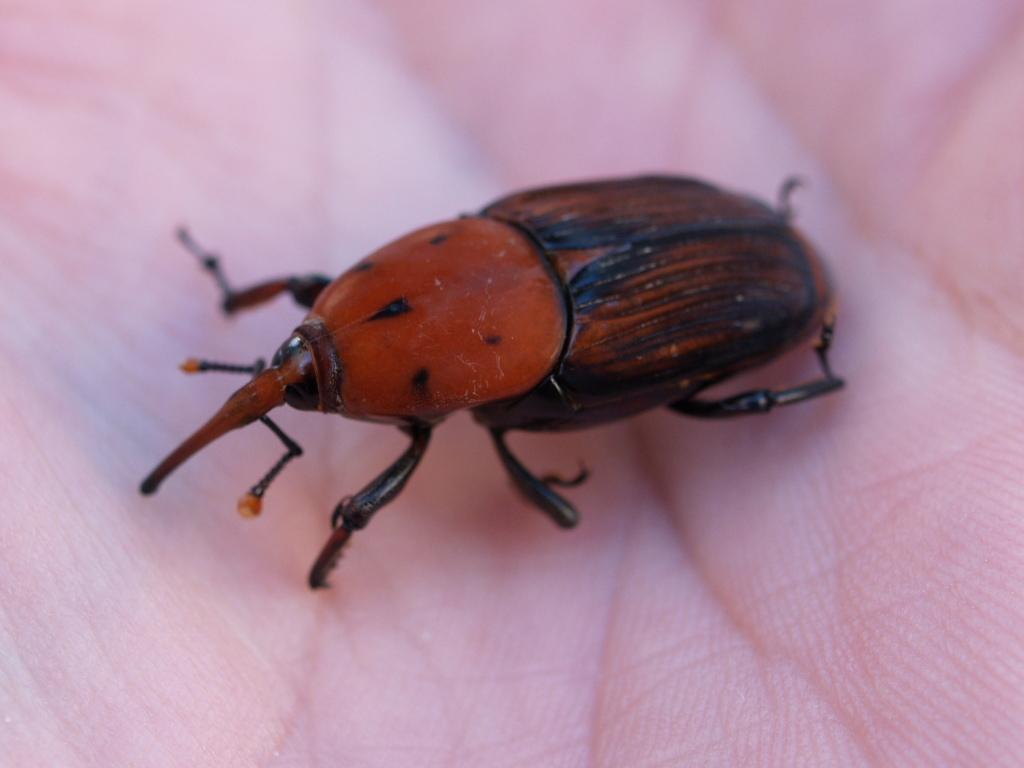What is the main subject of the image? The main subject of the image is a person. What is the person doing in the image? The person is holding a camera and taking a picture. What can be seen in the background of the image? There is a building in the background of the image. How many people are present in the image? There is only one person present in the image. What type of reaction can be seen on the person's feet in the image? There is no information about the person's feet in the image, and therefore no reaction can be observed. 